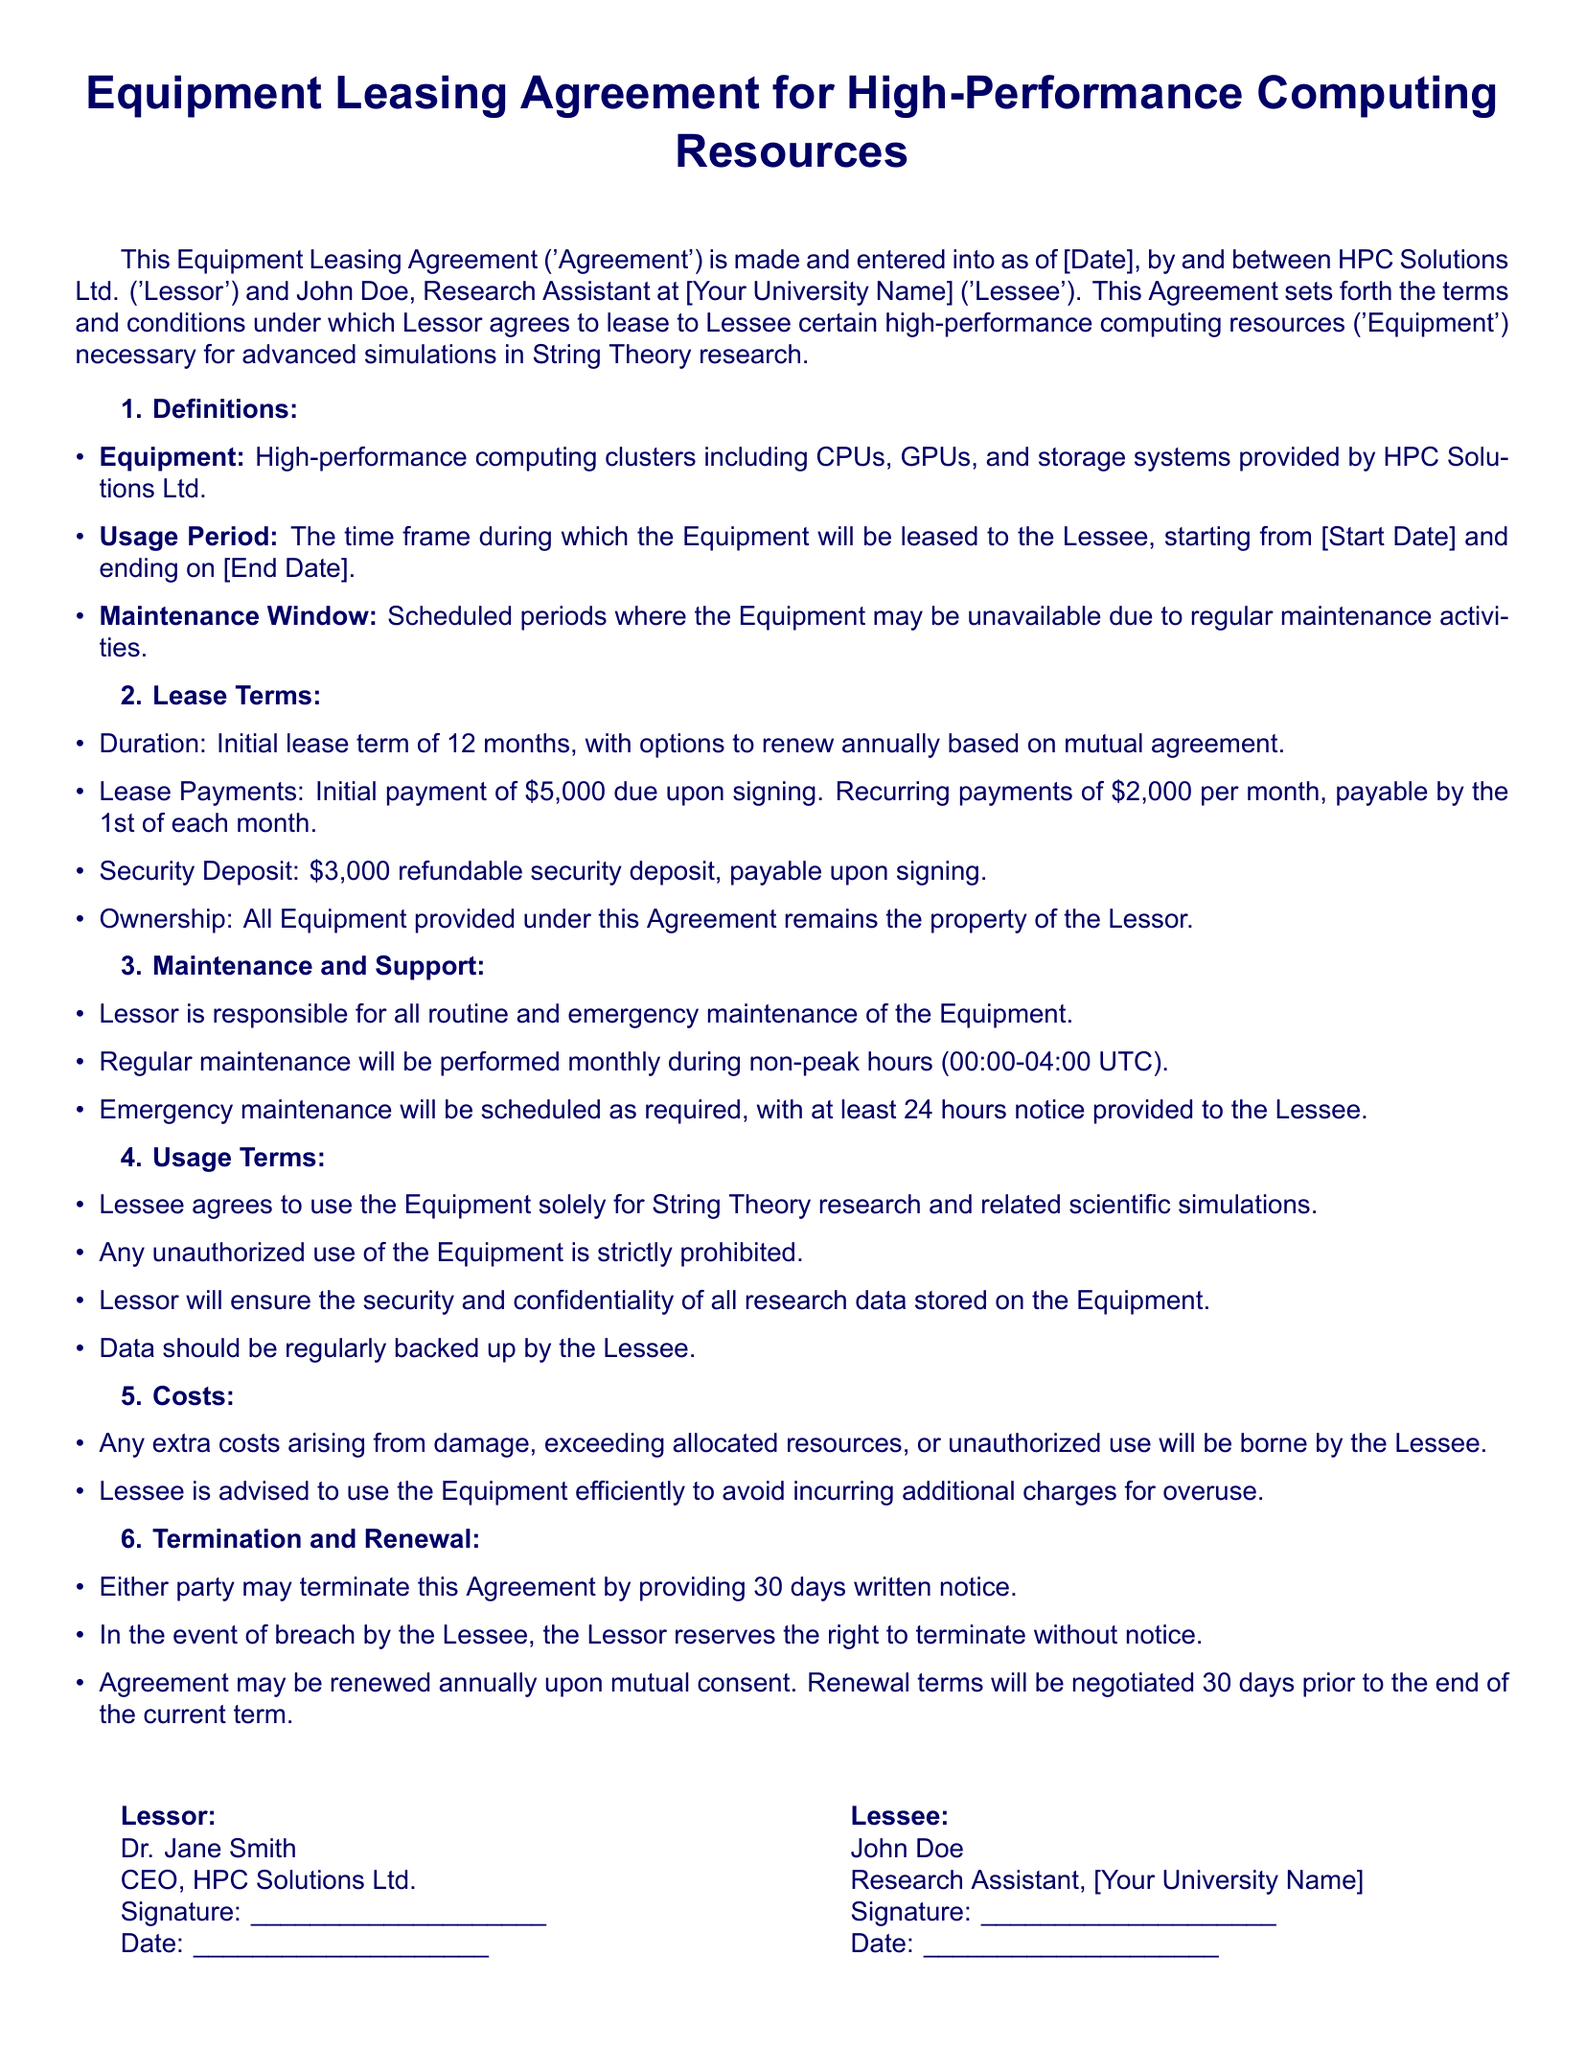What is the initial lease payment? The initial lease payment is specified as \$5,000 due upon signing.
Answer: \$5,000 What is the duration of the lease term? The document states that the initial lease term is for 12 months.
Answer: 12 months Who is the Lessor in this Agreement? The Agreement names HPC Solutions Ltd. as the Lessor.
Answer: HPC Solutions Ltd What is the security deposit amount? The security deposit is listed as \$3,000 refundable upon signing.
Answer: \$3,000 When is regular maintenance scheduled? Regular maintenance will be performed monthly during non-peak hours from 00:00 to 04:00 UTC.
Answer: 00:00-04:00 UTC What is the consequence of unauthorized use of Equipment? Unauthorized use is strictly prohibited according to the Usage Terms section.
Answer: Strictly prohibited How much notice is required for either party to terminate the Agreement? The document specifies that 30 days written notice is required for termination by either party.
Answer: 30 days What is the Lessee's responsibility regarding research data? The document mentions that data should be regularly backed up by the Lessee.
Answer: Regularly backed up What happens if there is a breach by the Lessee? In the event of breach by the Lessee, the Lessor reserves the right to terminate without notice.
Answer: Terminate without notice How often is emergency maintenance scheduled? Emergency maintenance will be scheduled as required, with at least 24 hours notice provided to the Lessee.
Answer: As required 